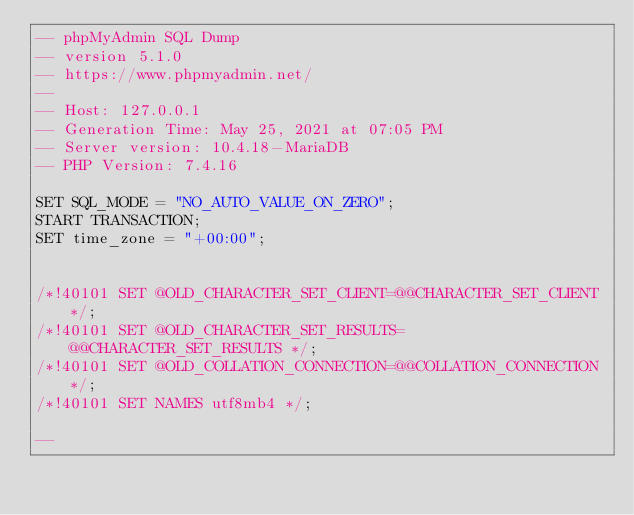<code> <loc_0><loc_0><loc_500><loc_500><_SQL_>-- phpMyAdmin SQL Dump
-- version 5.1.0
-- https://www.phpmyadmin.net/
--
-- Host: 127.0.0.1
-- Generation Time: May 25, 2021 at 07:05 PM
-- Server version: 10.4.18-MariaDB
-- PHP Version: 7.4.16

SET SQL_MODE = "NO_AUTO_VALUE_ON_ZERO";
START TRANSACTION;
SET time_zone = "+00:00";


/*!40101 SET @OLD_CHARACTER_SET_CLIENT=@@CHARACTER_SET_CLIENT */;
/*!40101 SET @OLD_CHARACTER_SET_RESULTS=@@CHARACTER_SET_RESULTS */;
/*!40101 SET @OLD_COLLATION_CONNECTION=@@COLLATION_CONNECTION */;
/*!40101 SET NAMES utf8mb4 */;

--</code> 